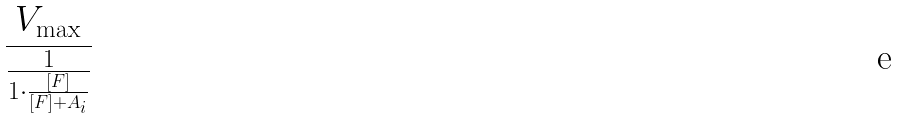Convert formula to latex. <formula><loc_0><loc_0><loc_500><loc_500>\frac { V _ { \max } } { \frac { 1 } { 1 \cdot \frac { [ F ] } { [ F ] + A _ { i } } } }</formula> 